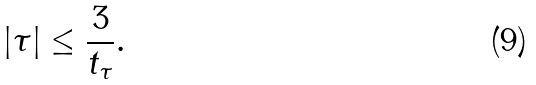<formula> <loc_0><loc_0><loc_500><loc_500>| \tau | \leq \frac { 3 } { t _ { \tau } } .</formula> 